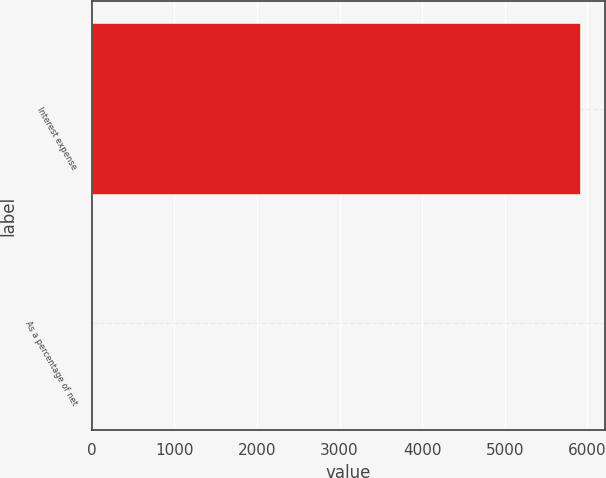Convert chart. <chart><loc_0><loc_0><loc_500><loc_500><bar_chart><fcel>Interest expense<fcel>As a percentage of net<nl><fcel>5916<fcel>0.1<nl></chart> 